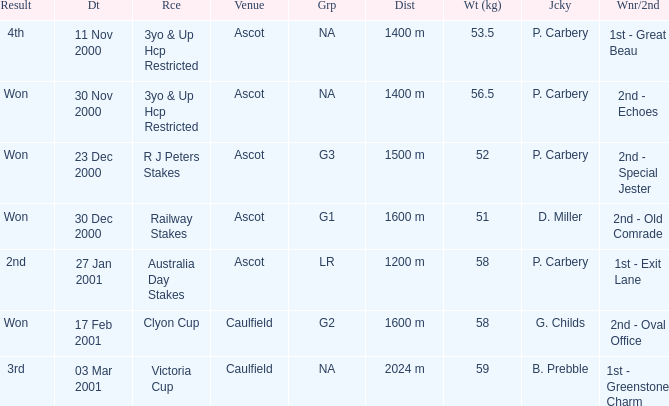What group info is available for the 56.5 kg weight? NA. 